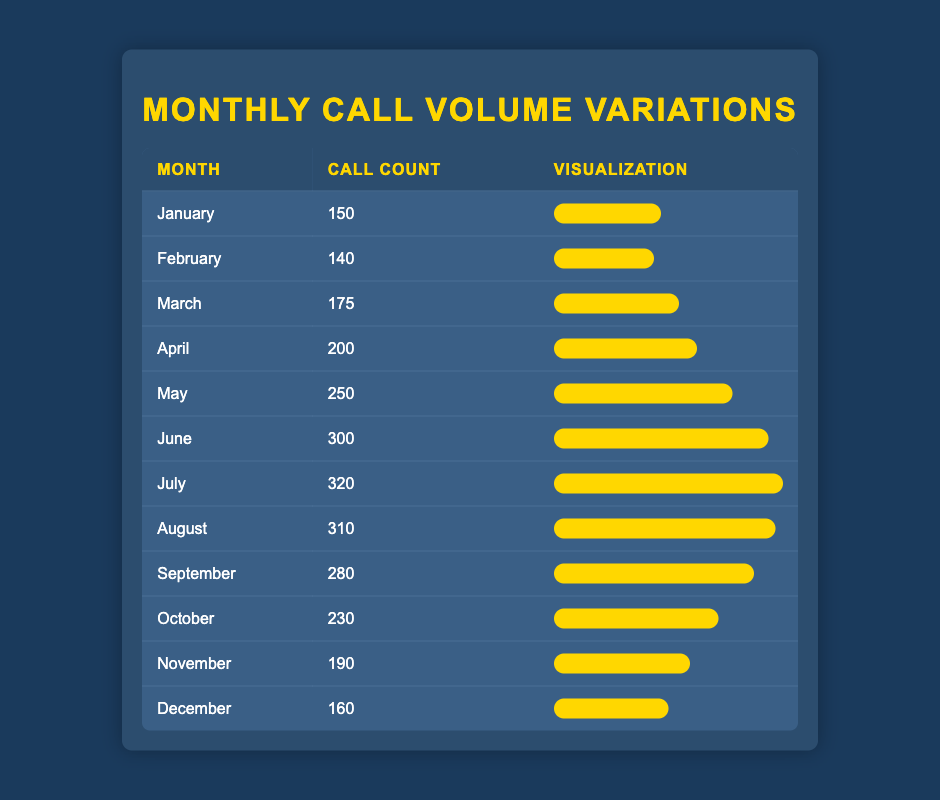What is the call count for June? The table clearly lists the call count for each month. For June, it states the call count is 300.
Answer: 300 Which month had the highest call count? By examining the call counts, July has the highest value listed, which is 320.
Answer: July What is the average call volume for the first half of the year (January to June)? The sum of the call counts for the first half is (150 + 140 + 175 + 200 + 250 + 300) = 1215. There are 6 months in total, so the average is 1215 / 6 = 202.5.
Answer: 202.5 Did the call count in any month exceed 300? Looking through the table, we see that July has a call count of 320, which indeed exceeds 300.
Answer: Yes What is the difference in call volume between the highest and lowest months? The highest call count is in July with 320 calls, while the lowest is in February with 140 calls. The difference is 320 - 140 = 180.
Answer: 180 What months had a call count of less than 200? By checking the table, the months with a call count of less than 200 are January (150), February (140), and November (190).
Answer: January, February, November If we consider the call volume from May to December, what is the total call count? The call counts from May (250) to December (160) are: 250 + 300 + 320 + 310 + 280 + 230 + 190 + 160 = 1750.
Answer: 1750 Is the call volume in December higher than that in October? Comparing December (160 calls) and October (230 calls), October has a higher count, so the answer is no.
Answer: No 